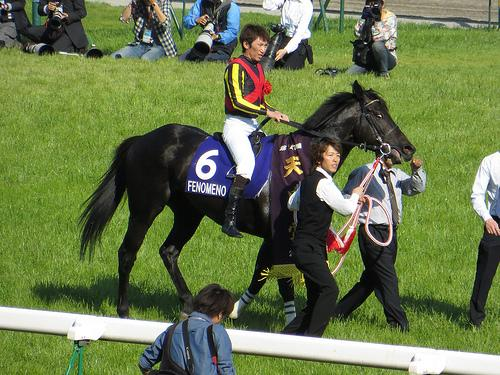What is the activity that multiple people are doing in the background? There are people taking photographs and others leading a horse while walking with it. What kind of animal, apart from the horse, can be seen in the image? There are no other animals visible in the image. Select the best caption summarizing the image regarding the main subject and their action. A jockey on a black racing horse during a race while people take pictures and guide the horse. Who is guiding the black racing horse, and what are they wearing? A man in a blue shirt and another man in a suit are guiding the black racing horse. In a single sentence, describe the landscape of the image in terms of vegetation and setting. The landscape consists of a green grass field with a large white railing in the foreground. Describe the appearance of the horse and its rider in the image. The horse is black, racing with its tail extended, and the rider is a male jockey wearing white pants, riding on top of the horse. Identify the most dominant color in the foreground of this image. White, as there is a large white metal railing in the foreground. 